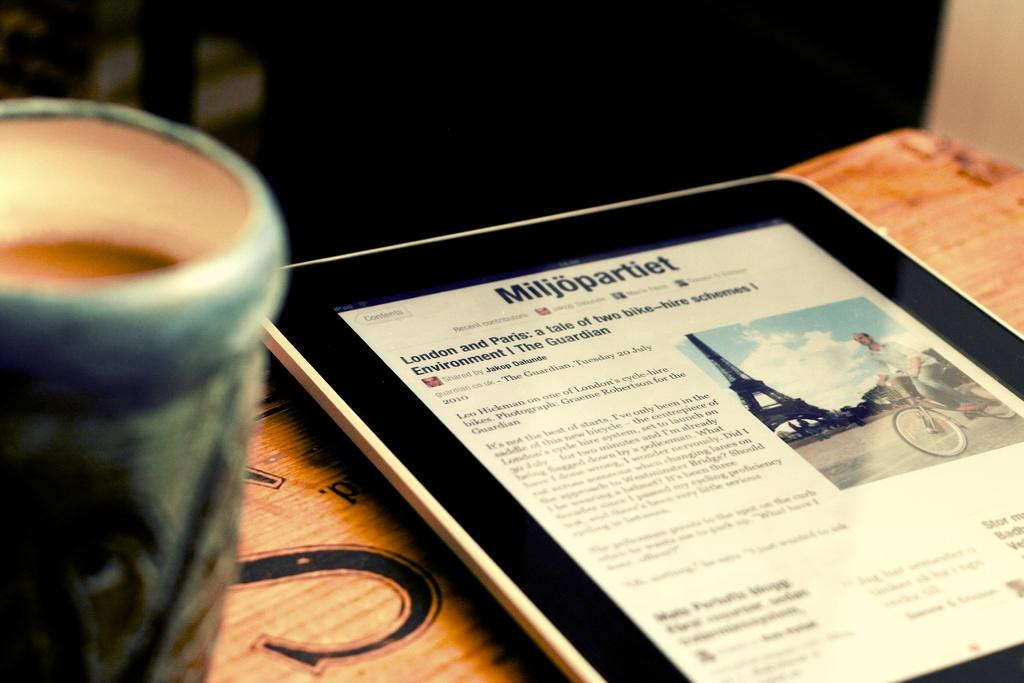What object can be seen in the image that is not a cup? There is a gadget in the image. What is inside the cup in the image? There is a drink in the cup. Where are both the gadget and the cup located in the image? Both the gadget and the cup are on a table. What can be said about the lighting in the image? The background of the image is dark. What type of store is visible in the background of the image? There is no store visible in the background of the image; the background is dark. What question is being asked by the gadget in the image? The gadget in the image is not capable of asking questions, as it is an inanimate object. 